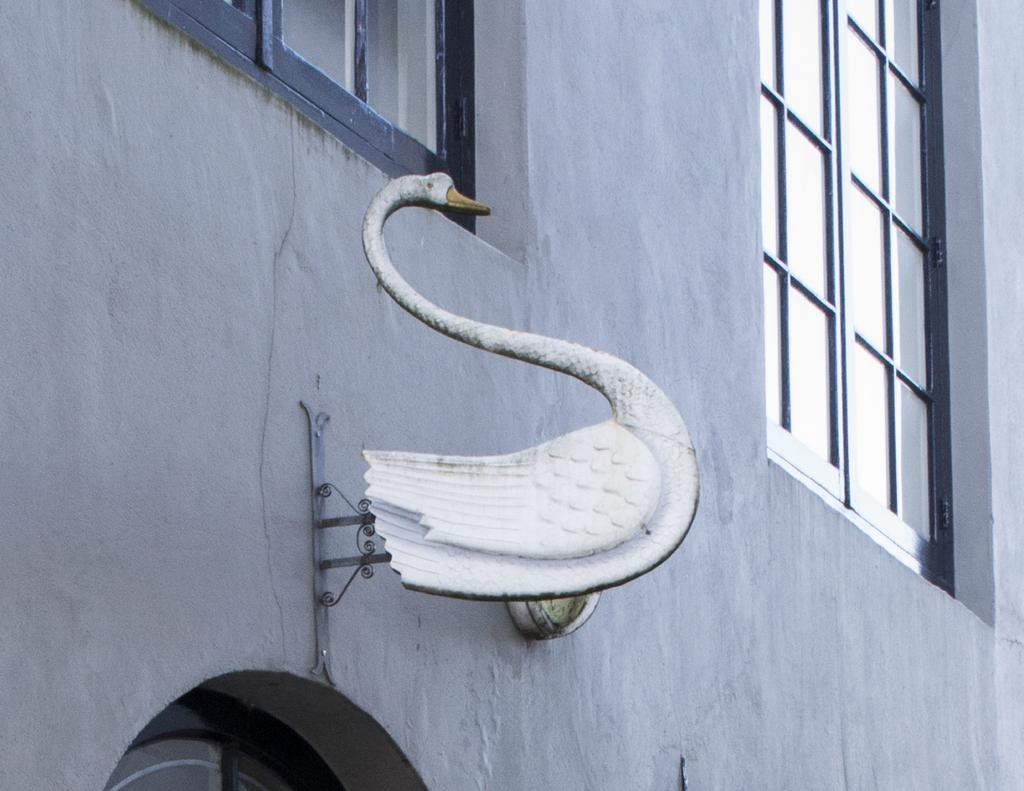What is the main structure visible in the picture? There is a building wall in the picture. Where are the windows located on the wall? There is a window on the right side of the wall and another window on the top of the wall. What is the shape of the object in the center of the picture? There is a board in the shape of a swan in the center of the picture. Can you hear the owl talking to the swan in the picture? There is no owl or talking in the picture; it only features a building wall, windows, and a board in the shape of a swan. 